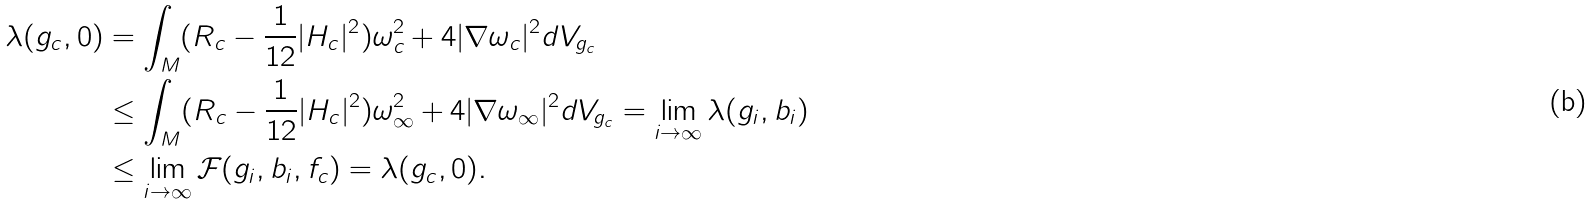Convert formula to latex. <formula><loc_0><loc_0><loc_500><loc_500>\lambda ( g _ { c } , 0 ) & = \int _ { M } ( R _ { c } - \frac { 1 } { 1 2 } | H _ { c } | ^ { 2 } ) \omega _ { c } ^ { 2 } + 4 | \nabla \omega _ { c } | ^ { 2 } d V _ { g _ { c } } \\ & \leq \int _ { M } ( R _ { c } - \frac { 1 } { 1 2 } | H _ { c } | ^ { 2 } ) \omega ^ { 2 } _ { \infty } + 4 | \nabla \omega _ { \infty } | ^ { 2 } d V _ { g _ { c } } = \lim _ { i \to \infty } \lambda ( g _ { i } , b _ { i } ) \\ & \leq \lim _ { i \to \infty } \mathcal { F } ( g _ { i } , b _ { i } , f _ { c } ) = \lambda ( g _ { c } , 0 ) .</formula> 